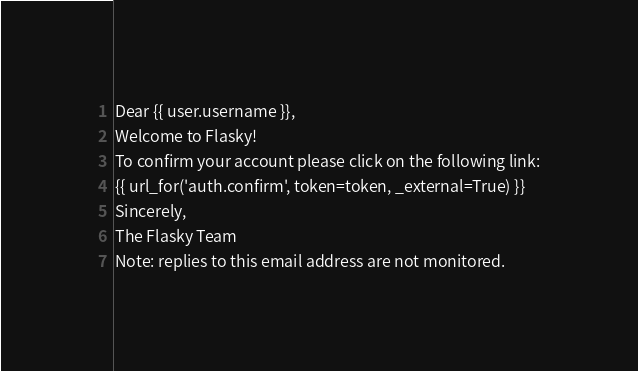<code> <loc_0><loc_0><loc_500><loc_500><_HTML_>Dear {{ user.username }},
Welcome to Flasky!
To confirm your account please click on the following link:
{{ url_for('auth.confirm', token=token, _external=True) }}
Sincerely,
The Flasky Team
Note: replies to this email address are not monitored.
</code> 